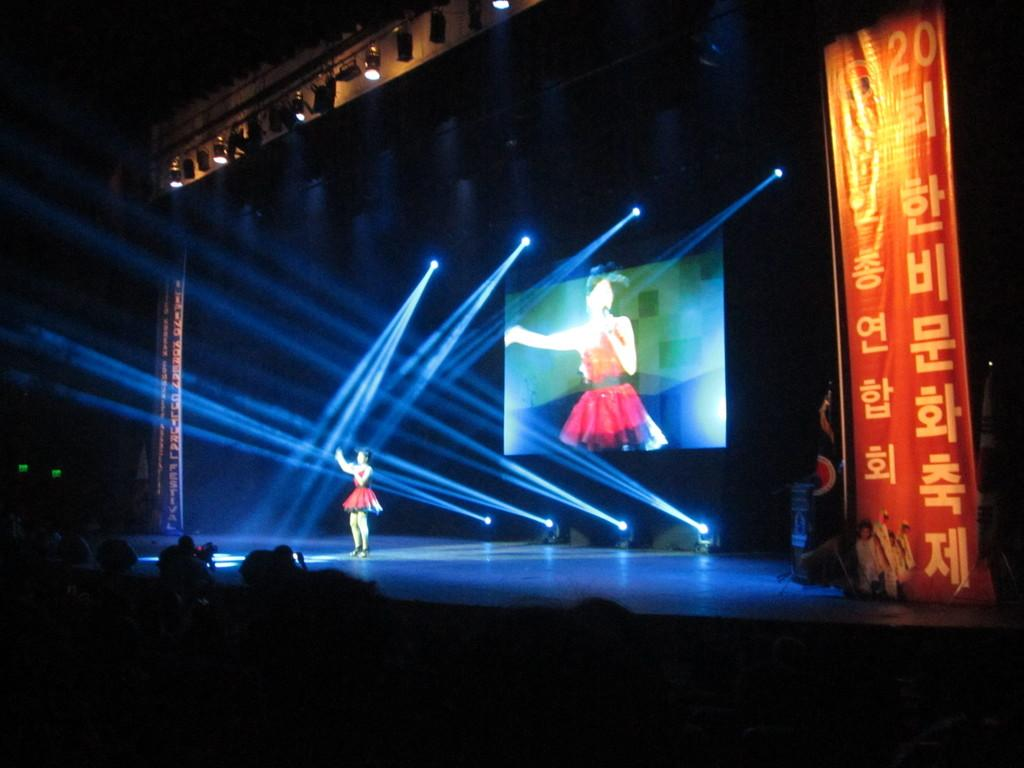What is the woman in the image doing? The woman is standing on a stage. What can be seen in the background behind the woman? There are lights and a screen in the background. Is there any text visible in the image? Yes, there is a poster with some text on the right side. What is the source of illumination at the top of the image? There are lights at the top of the image. Can you tell me how much milk is being poured into the dock in the image? There is no dock or milk present in the image. 